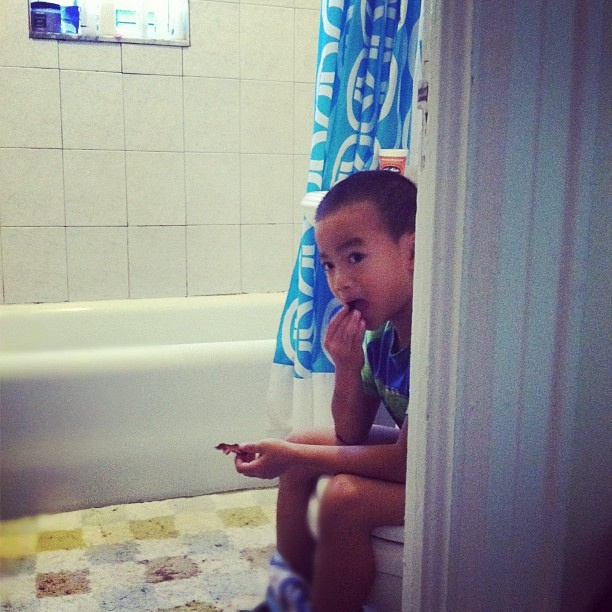Describe the objects in this image and their specific colors. I can see people in beige, purple, and brown tones and toilet in beige, purple, black, and darkgray tones in this image. 